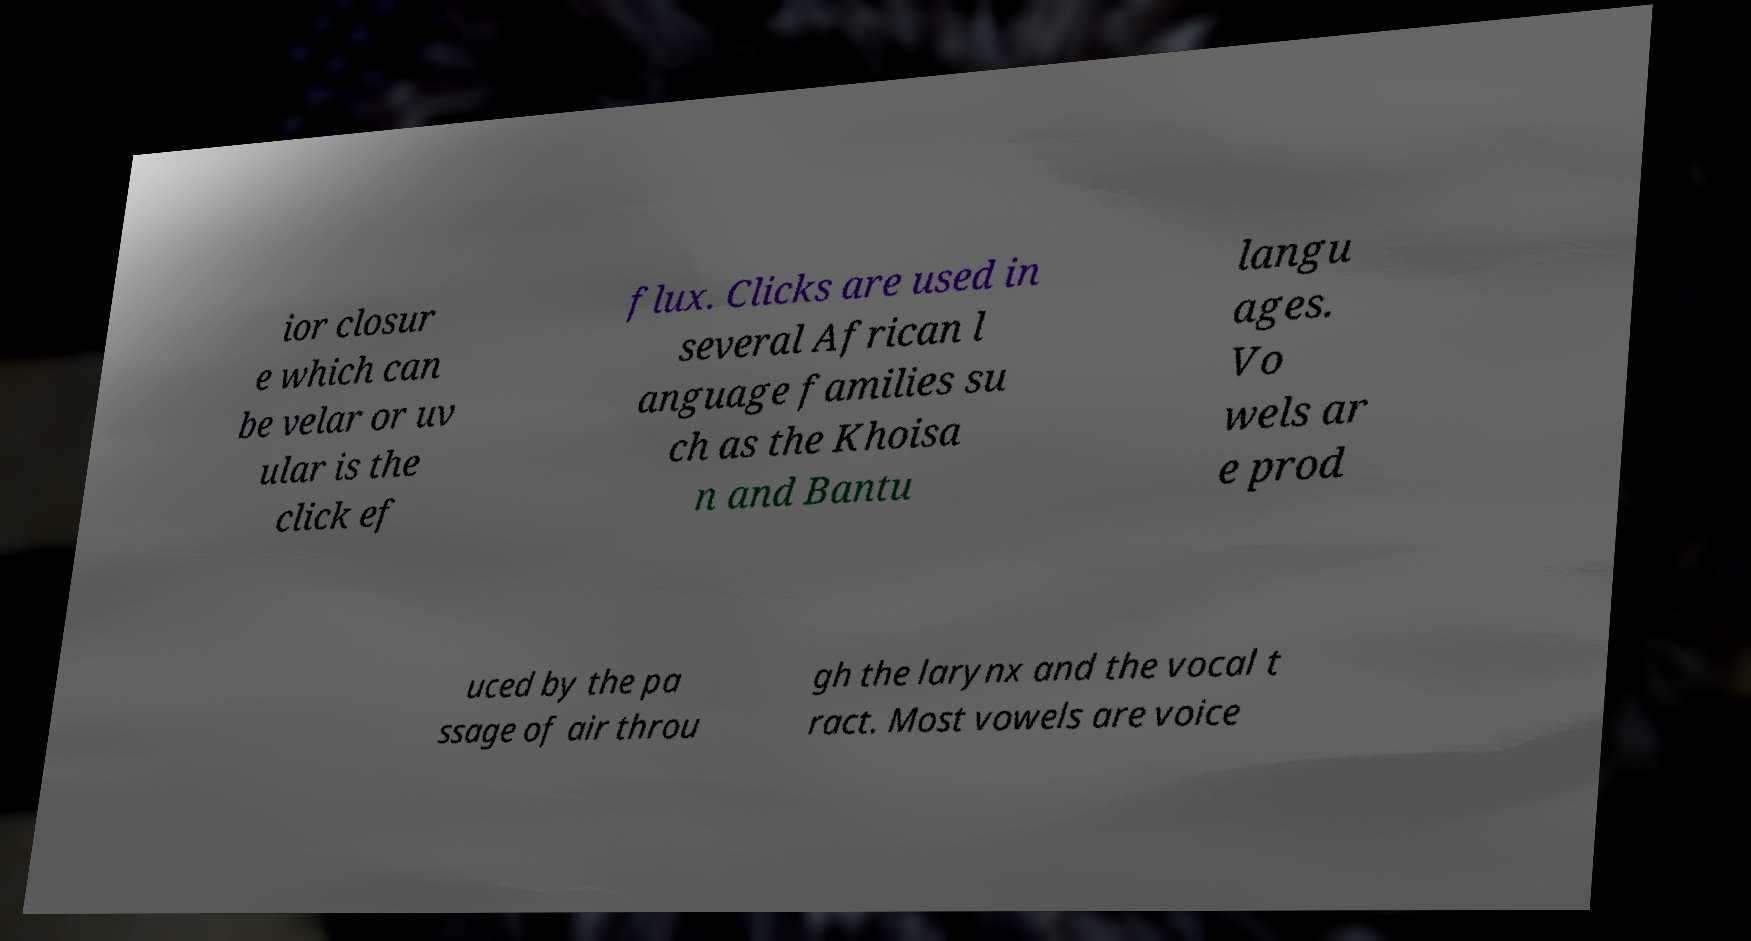There's text embedded in this image that I need extracted. Can you transcribe it verbatim? ior closur e which can be velar or uv ular is the click ef flux. Clicks are used in several African l anguage families su ch as the Khoisa n and Bantu langu ages. Vo wels ar e prod uced by the pa ssage of air throu gh the larynx and the vocal t ract. Most vowels are voice 